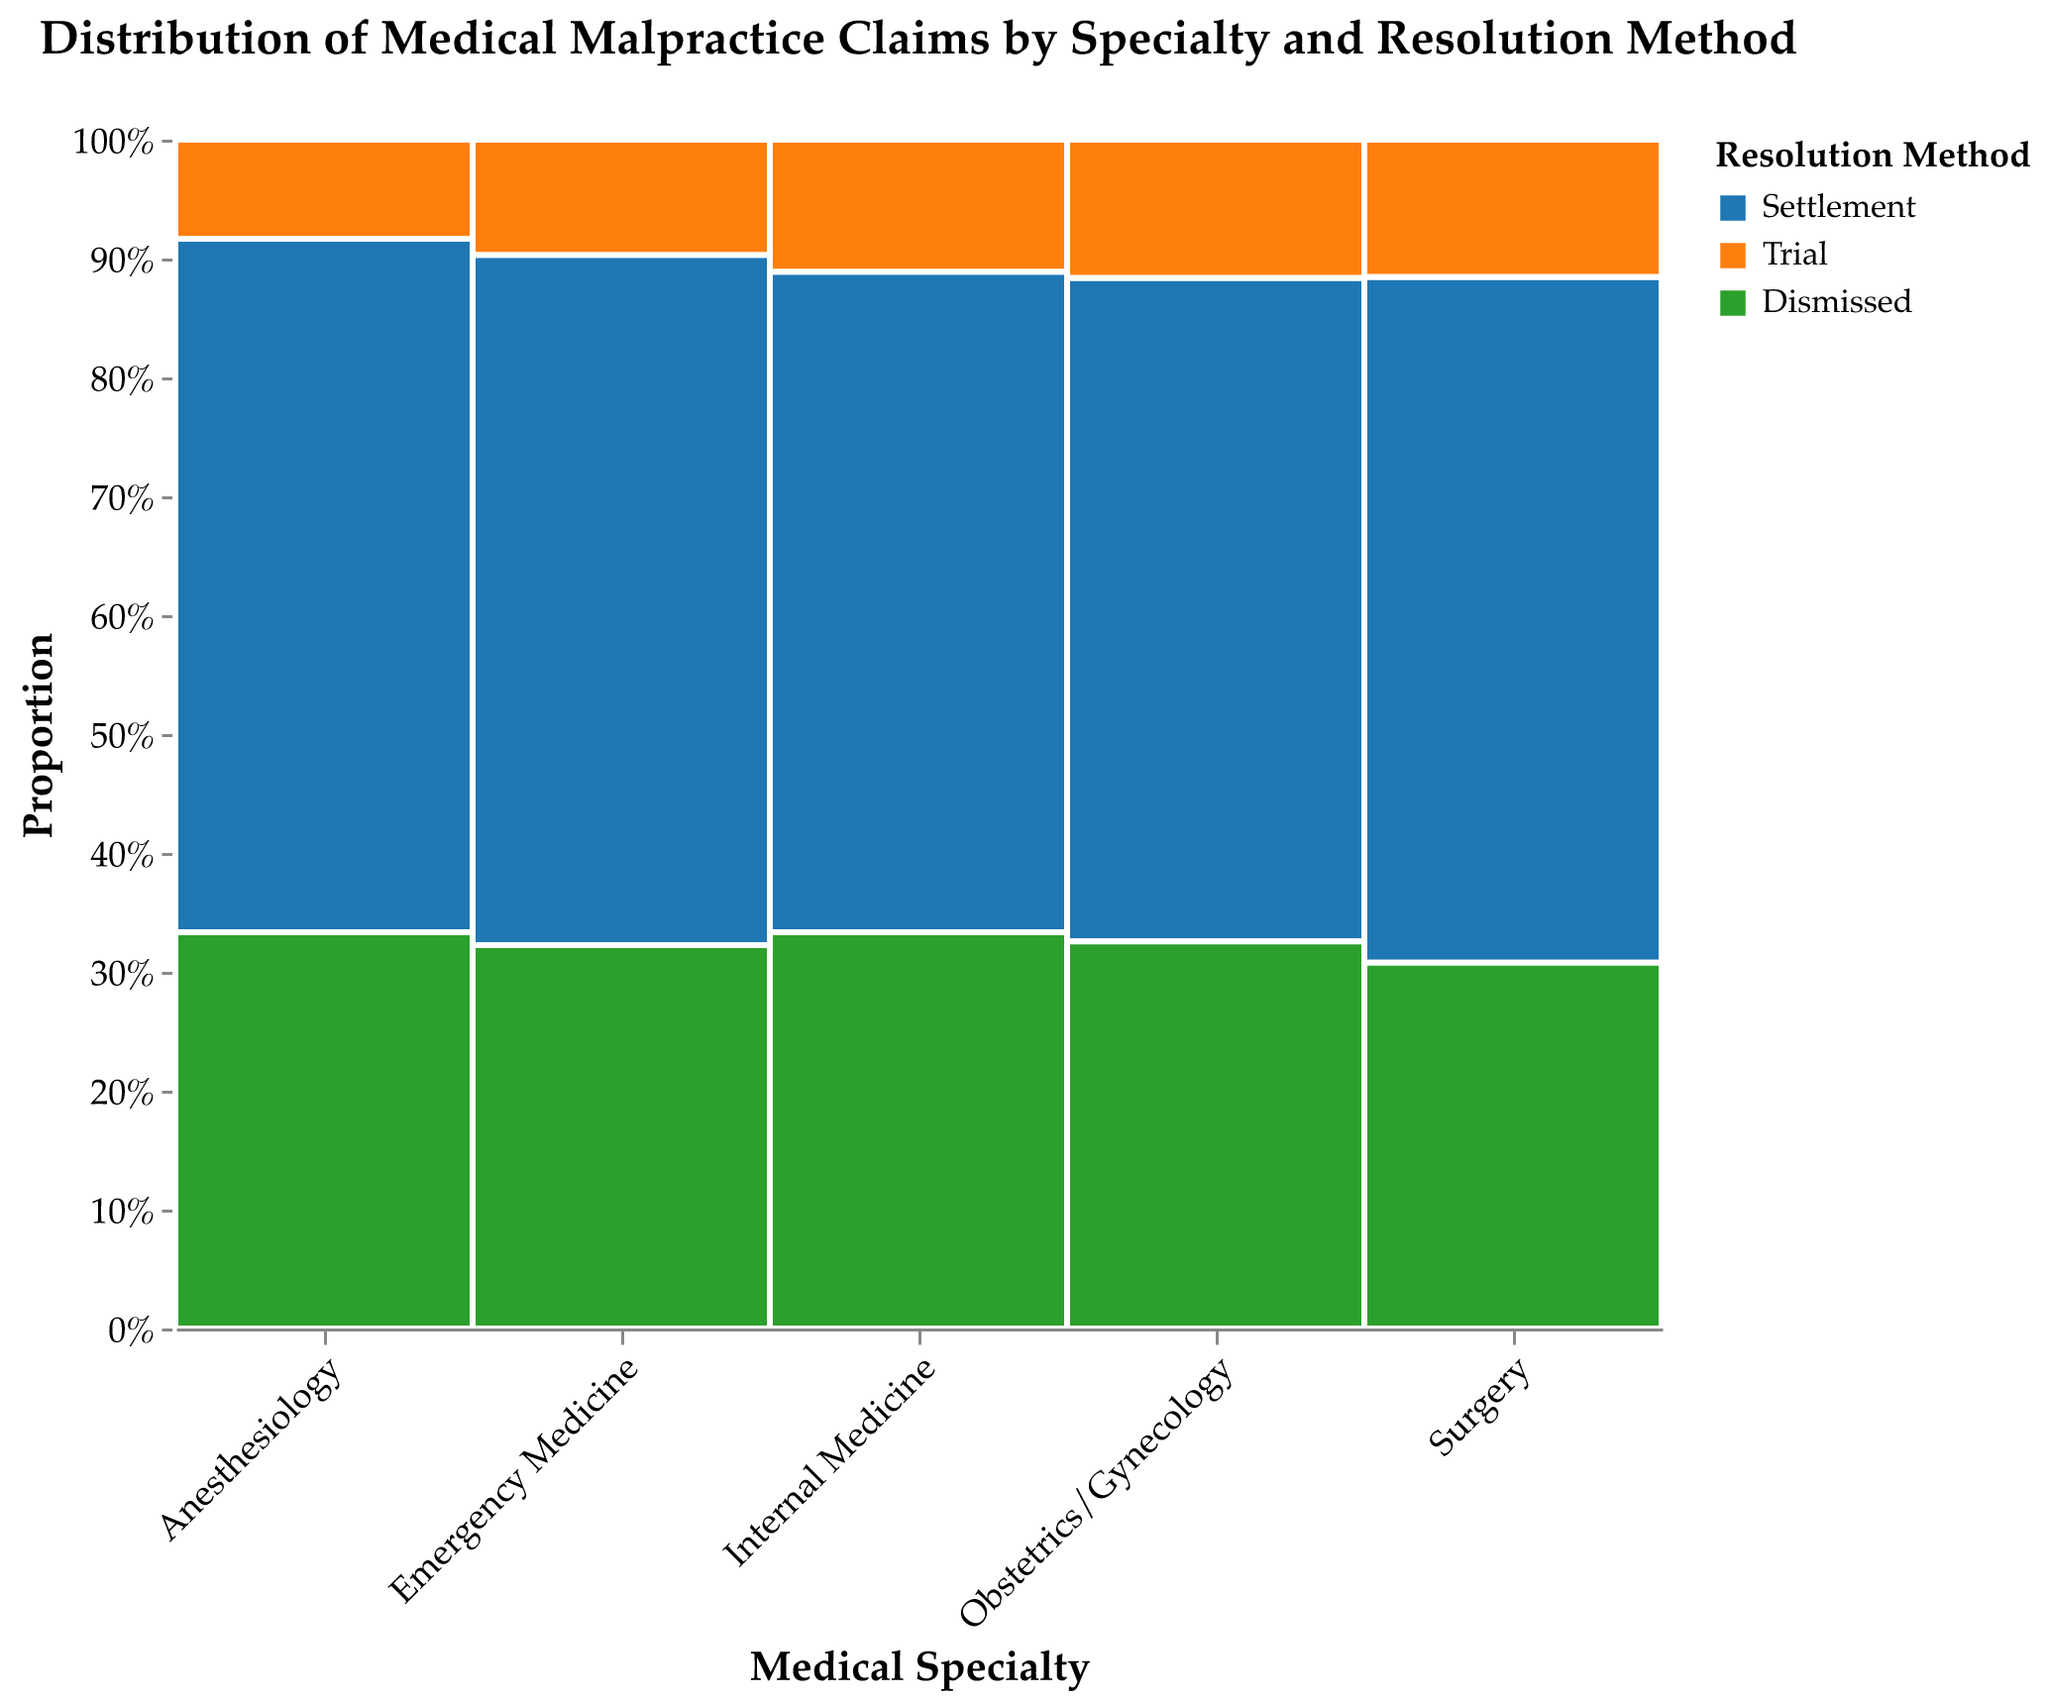What's the title of the figure? The title is usually displayed at the top of a figure. This title helps understand the overall theme or subject of the plot.
Answer: Distribution of Medical Malpractice Claims by Specialty and Resolution Method Which medical specialty has the highest number of settlements? The plot's x-axis represents medical specialties and settlements are colored distinctly. By comparing the heights of rectangles marked as "Settlement" for each specialty, Surgery has the tallest bar.
Answer: Surgery Which resolution method is least common in Emergency Medicine? For Emergency Medicine, compare the sizes of the three resolution method's rectangles. The smallest rectangle represents the least common resolution method.
Answer: Trial What is the proportion of dismissed malpractice claims for Internal Medicine? Locate the bar for Internal Medicine, and find the segment labeled "Dismissed." The y-axis represents proportion, and the position of the top of the rectangle gives the required value.
Answer: Approximately 0.33 or 33% Compare the number of malpractice claims settled and dismissed for Obstetrics/Gynecology. Which is higher? For Obstetrics/Gynecology, compare the heights of the "Settlement" and "Dismissed" rectangles. The taller rectangle indicates a higher number.
Answer: Settled What percentage of the total malpractice claims for Anesthesiology is taken to trial? Find the segment for "Trial" under Anesthesiology and use the y-axis to determine the proportion, then convert this proportion to a percentage.
Answer: Approximately 9% In which specialty is the proportion of trials versus settlements highest? Compare the height of the "Trial" rectangle to the "Settlement" rectangle for each specialty. The specialty where the ratio between these is highest has the highest proportion of trials versus settlements.
Answer: Surgery How does the proportion of settled claims in Emergency Medicine compare with those in Internal Medicine? Compare the segments of "Settlement" for Emergency Medicine (approximately 0.53) and Internal Medicine (approximately 0.50). Emergency Medicine has a slightly higher proportion of settled claims.
Answer: Higher in Emergency Medicine What can be inferred about the dismissal rates across different specialties? By observing the relative sizes of "Dismissed" segments across all specialties, one could deduce that dismissal rates vary, but no specialty has a dismissal rate disproportionately high or low compared to others.
Answer: Dismissal rates are relatively balanced Which specialty has the highest proportion of resolved malpractice claims through trials? Survey the "Trial" segments across all specialties, identifying the tallest segment relative to the other resolution methods within each specialty. Surgery has the highest proportion of trials.
Answer: Surgery 